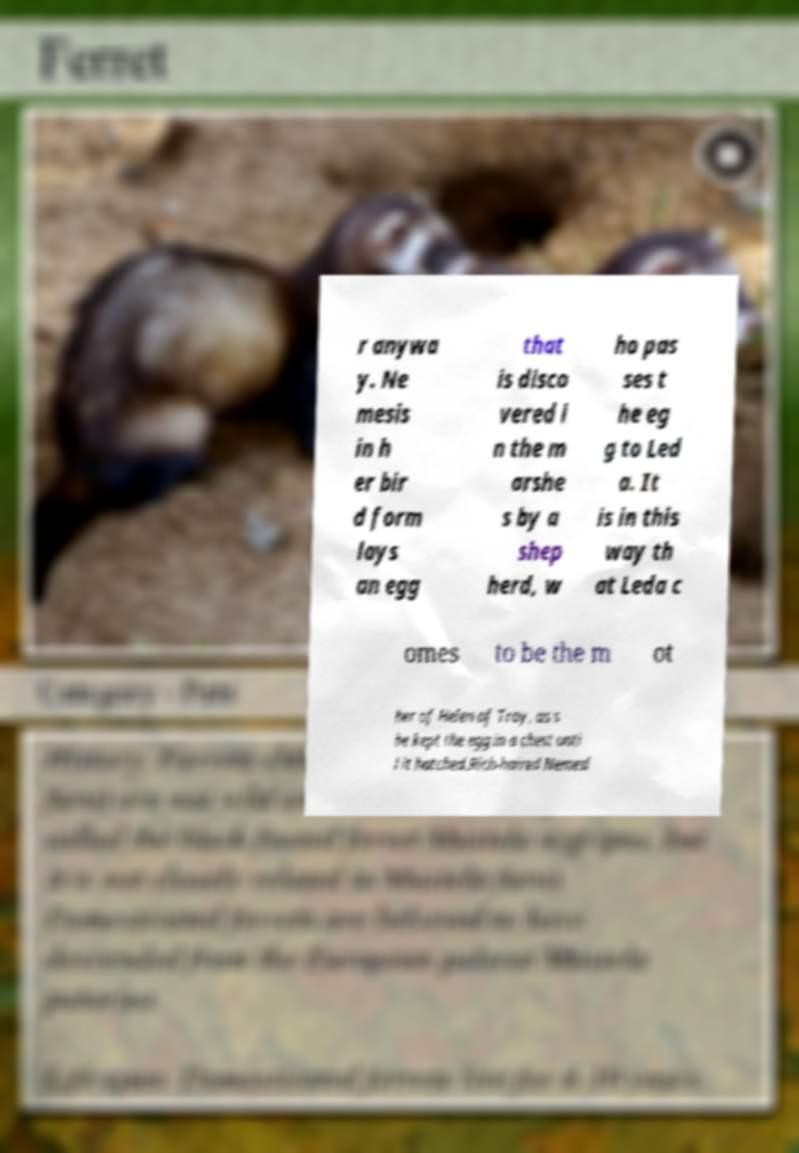There's text embedded in this image that I need extracted. Can you transcribe it verbatim? r anywa y. Ne mesis in h er bir d form lays an egg that is disco vered i n the m arshe s by a shep herd, w ho pas ses t he eg g to Led a. It is in this way th at Leda c omes to be the m ot her of Helen of Troy, as s he kept the egg in a chest unti l it hatched.Rich-haired Nemesi 